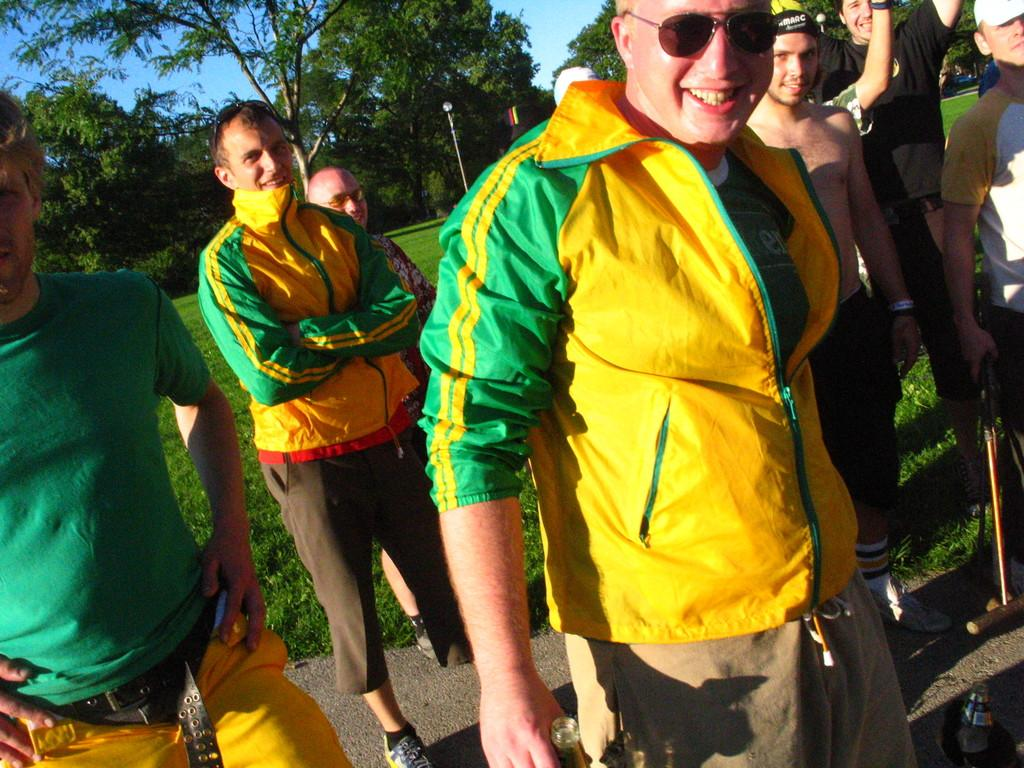How many people are in the image? There is a group of people in the image. What are the people doing in the image? The people are standing on the ground and smiling. What can be seen in the background of the image? There are poles, trees, and the sky visible in the background of the image. What type of seed is being planted by the people in the image? There is no seed or planting activity depicted in the image; the people are simply standing and smiling. 